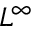Convert formula to latex. <formula><loc_0><loc_0><loc_500><loc_500>L ^ { \infty }</formula> 